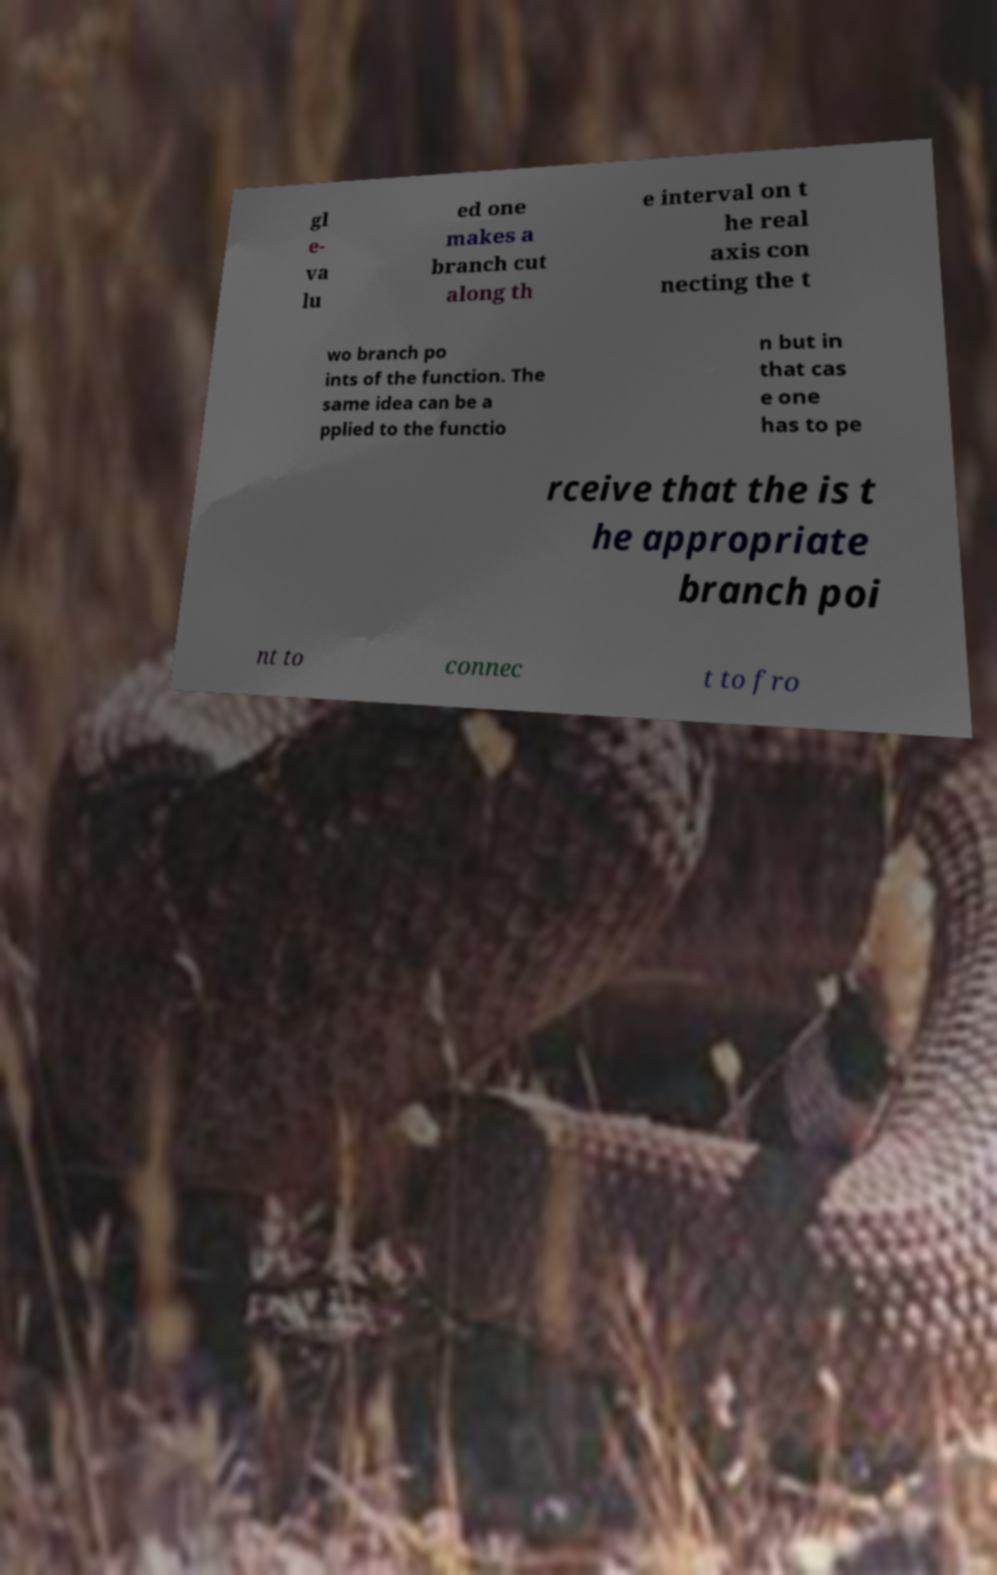Could you extract and type out the text from this image? gl e- va lu ed one makes a branch cut along th e interval on t he real axis con necting the t wo branch po ints of the function. The same idea can be a pplied to the functio n but in that cas e one has to pe rceive that the is t he appropriate branch poi nt to connec t to fro 